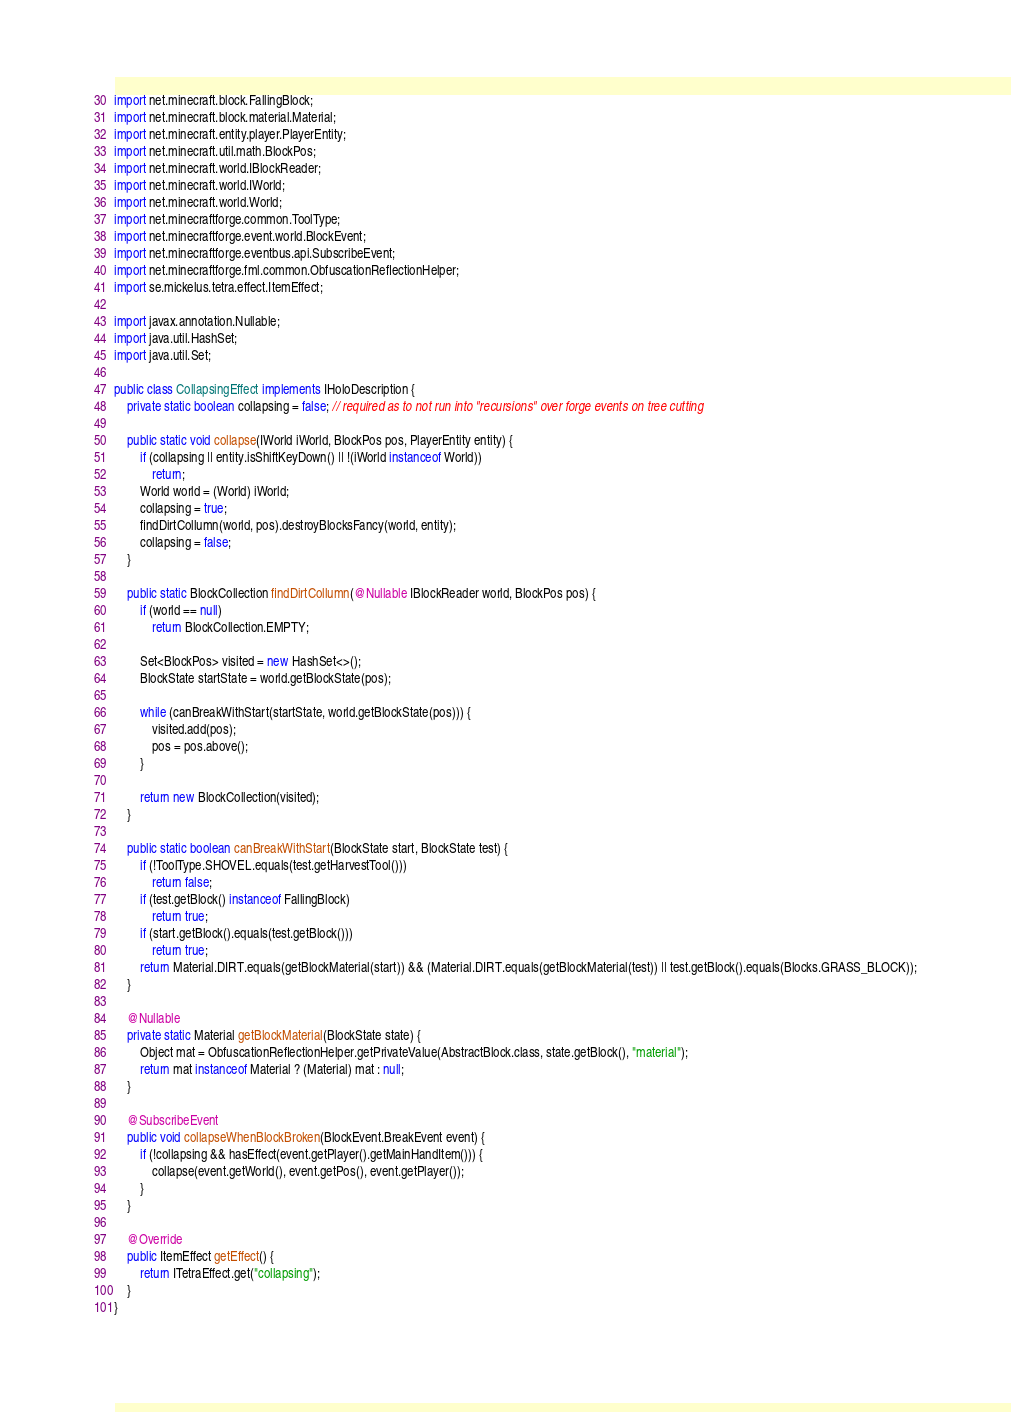Convert code to text. <code><loc_0><loc_0><loc_500><loc_500><_Java_>import net.minecraft.block.FallingBlock;
import net.minecraft.block.material.Material;
import net.minecraft.entity.player.PlayerEntity;
import net.minecraft.util.math.BlockPos;
import net.minecraft.world.IBlockReader;
import net.minecraft.world.IWorld;
import net.minecraft.world.World;
import net.minecraftforge.common.ToolType;
import net.minecraftforge.event.world.BlockEvent;
import net.minecraftforge.eventbus.api.SubscribeEvent;
import net.minecraftforge.fml.common.ObfuscationReflectionHelper;
import se.mickelus.tetra.effect.ItemEffect;

import javax.annotation.Nullable;
import java.util.HashSet;
import java.util.Set;

public class CollapsingEffect implements IHoloDescription {
	private static boolean collapsing = false; // required as to not run into "recursions" over forge events on tree cutting

	public static void collapse(IWorld iWorld, BlockPos pos, PlayerEntity entity) {
		if (collapsing || entity.isShiftKeyDown() || !(iWorld instanceof World))
			return;
		World world = (World) iWorld;
		collapsing = true;
		findDirtCollumn(world, pos).destroyBlocksFancy(world, entity);
		collapsing = false;
	}

	public static BlockCollection findDirtCollumn(@Nullable IBlockReader world, BlockPos pos) {
		if (world == null)
			return BlockCollection.EMPTY;

		Set<BlockPos> visited = new HashSet<>();
		BlockState startState = world.getBlockState(pos);

		while (canBreakWithStart(startState, world.getBlockState(pos))) {
			visited.add(pos);
			pos = pos.above();
		}

		return new BlockCollection(visited);
	}

	public static boolean canBreakWithStart(BlockState start, BlockState test) {
		if (!ToolType.SHOVEL.equals(test.getHarvestTool()))
			return false;
		if (test.getBlock() instanceof FallingBlock)
			return true;
		if (start.getBlock().equals(test.getBlock()))
			return true;
		return Material.DIRT.equals(getBlockMaterial(start)) && (Material.DIRT.equals(getBlockMaterial(test)) || test.getBlock().equals(Blocks.GRASS_BLOCK));
	}

	@Nullable
	private static Material getBlockMaterial(BlockState state) {
		Object mat = ObfuscationReflectionHelper.getPrivateValue(AbstractBlock.class, state.getBlock(), "material");
		return mat instanceof Material ? (Material) mat : null;
	}

	@SubscribeEvent
	public void collapseWhenBlockBroken(BlockEvent.BreakEvent event) {
		if (!collapsing && hasEffect(event.getPlayer().getMainHandItem())) {
			collapse(event.getWorld(), event.getPos(), event.getPlayer());
		}
	}

	@Override
	public ItemEffect getEffect() {
		return ITetraEffect.get("collapsing");
	}
}
</code> 